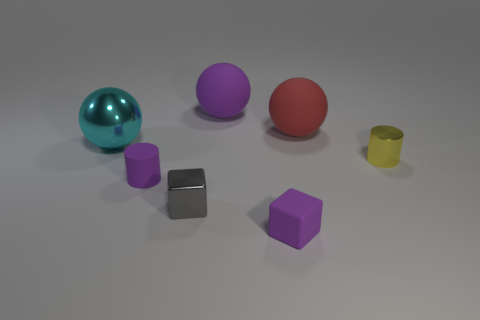Are there more gray shiny cubes that are in front of the gray block than blue metal cylinders?
Make the answer very short. No. What is the material of the tiny gray thing?
Make the answer very short. Metal. What shape is the big thing that is the same material as the big red ball?
Offer a very short reply. Sphere. There is a gray thing that is in front of the sphere that is right of the small purple rubber cube; what is its size?
Make the answer very short. Small. What is the color of the tiny shiny thing that is to the left of the yellow thing?
Your answer should be compact. Gray. Is there a purple rubber object of the same shape as the gray thing?
Make the answer very short. Yes. Are there fewer shiny things that are behind the purple cylinder than small rubber blocks that are behind the shiny ball?
Your answer should be compact. No. The rubber cylinder has what color?
Ensure brevity in your answer.  Purple. There is a matte object behind the red ball; is there a tiny purple matte cube that is behind it?
Make the answer very short. No. What number of purple cylinders have the same size as the rubber block?
Make the answer very short. 1. 